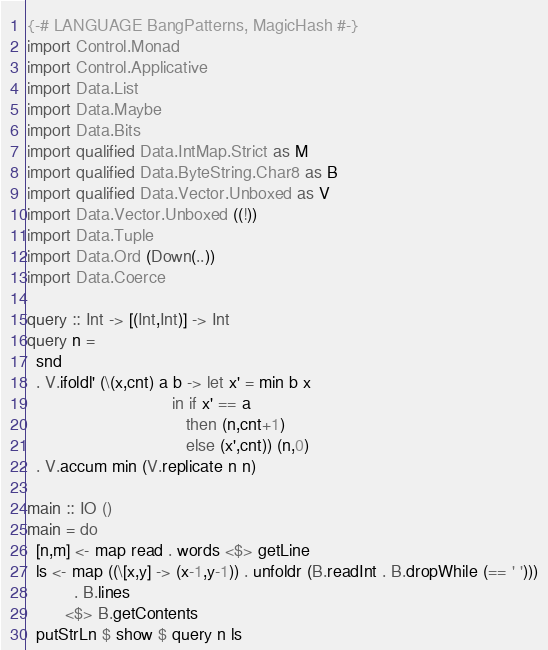Convert code to text. <code><loc_0><loc_0><loc_500><loc_500><_Haskell_>{-# LANGUAGE BangPatterns, MagicHash #-}
import Control.Monad
import Control.Applicative
import Data.List
import Data.Maybe
import Data.Bits
import qualified Data.IntMap.Strict as M
import qualified Data.ByteString.Char8 as B
import qualified Data.Vector.Unboxed as V
import Data.Vector.Unboxed ((!))
import Data.Tuple
import Data.Ord (Down(..))
import Data.Coerce
                                 
query :: Int -> [(Int,Int)] -> Int
query n =
  snd
  . V.ifoldl' (\(x,cnt) a b -> let x' = min b x
                               in if x' == a
                                  then (n,cnt+1)
                                  else (x',cnt)) (n,0)
  . V.accum min (V.replicate n n)
     
main :: IO ()
main = do
  [n,m] <- map read . words <$> getLine
  ls <- map ((\[x,y] -> (x-1,y-1)) . unfoldr (B.readInt . B.dropWhile (== ' ')))
          . B.lines
        <$> B.getContents
  putStrLn $ show $ query n ls</code> 